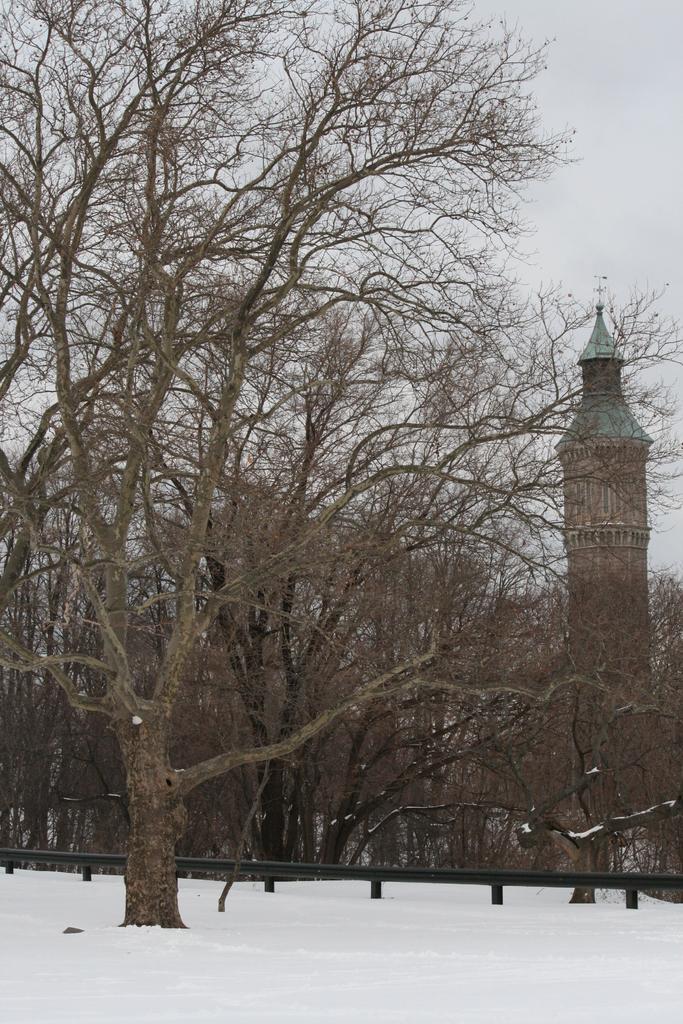In one or two sentences, can you explain what this image depicts? In this picture I can see buildings, trees and also we can see some snow. 